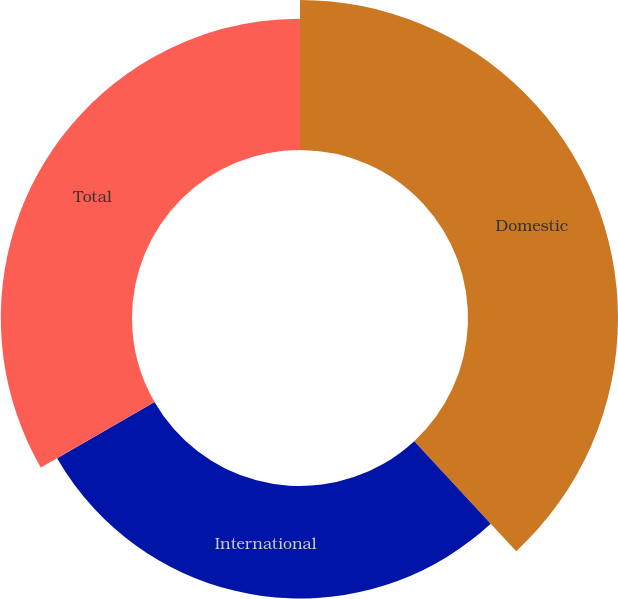<chart> <loc_0><loc_0><loc_500><loc_500><pie_chart><fcel>Domestic<fcel>International<fcel>Total<nl><fcel>38.1%<fcel>28.57%<fcel>33.33%<nl></chart> 